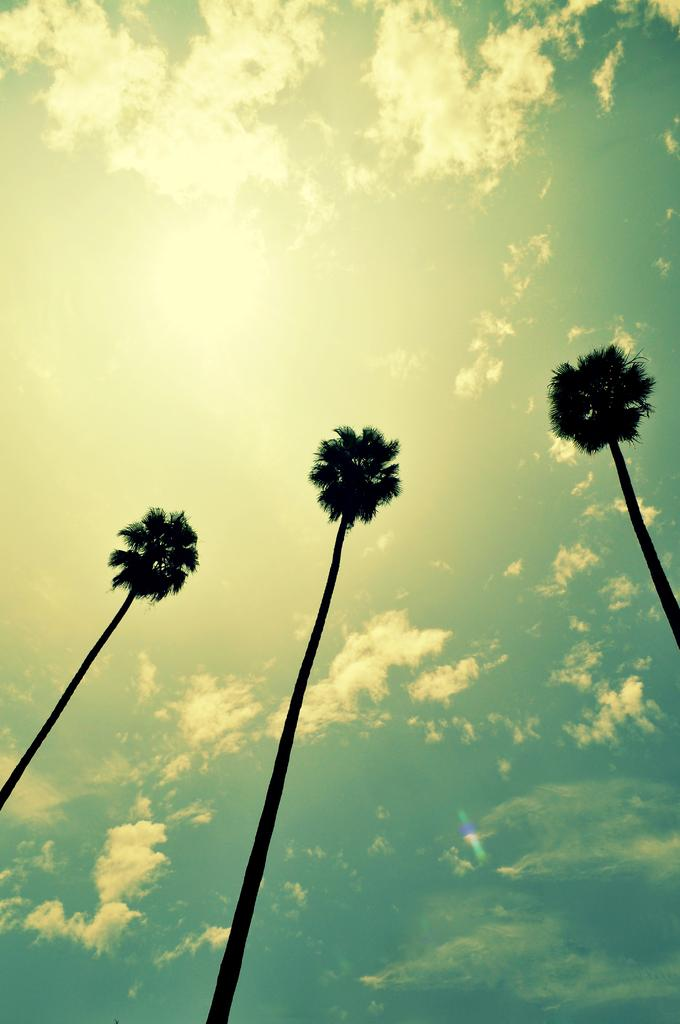What type of trees can be seen in the image? There are palm trees in the image. What part of the natural environment is visible in the image? The sky is visible in the image. What is the weather like in the image? The sky is sunny in the image. Is there a system of quicksand visible in the image? There is no mention of quicksand in the image, and it is not visible. 